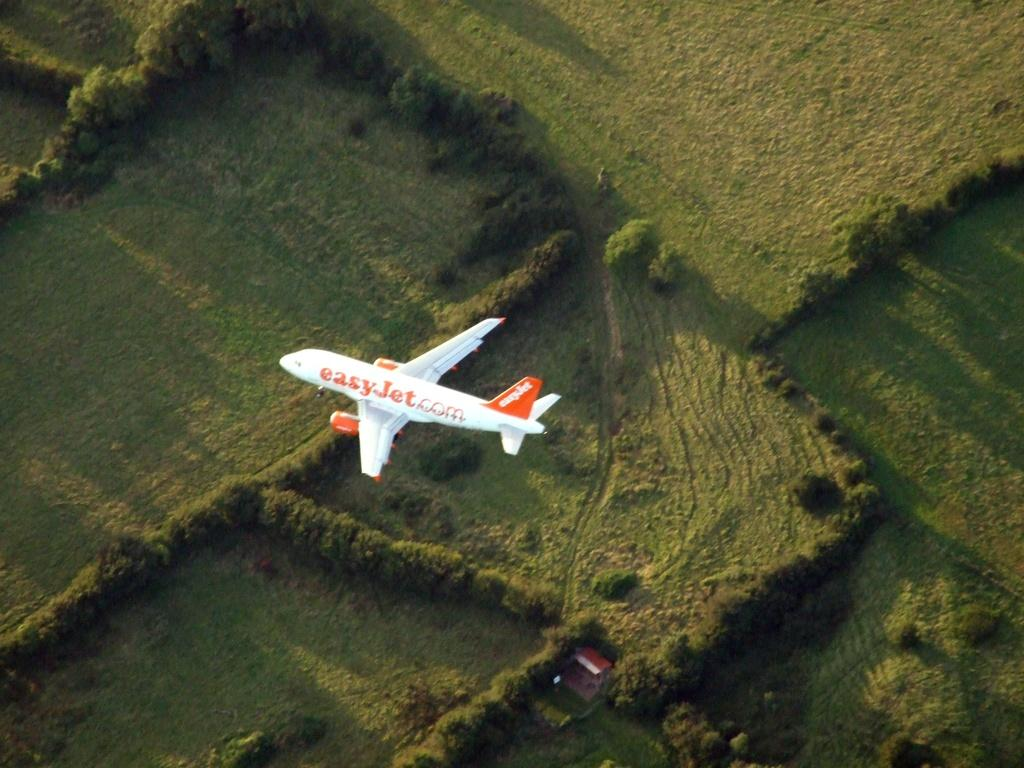<image>
Create a compact narrative representing the image presented. An easy jet.com flight in the air from above 